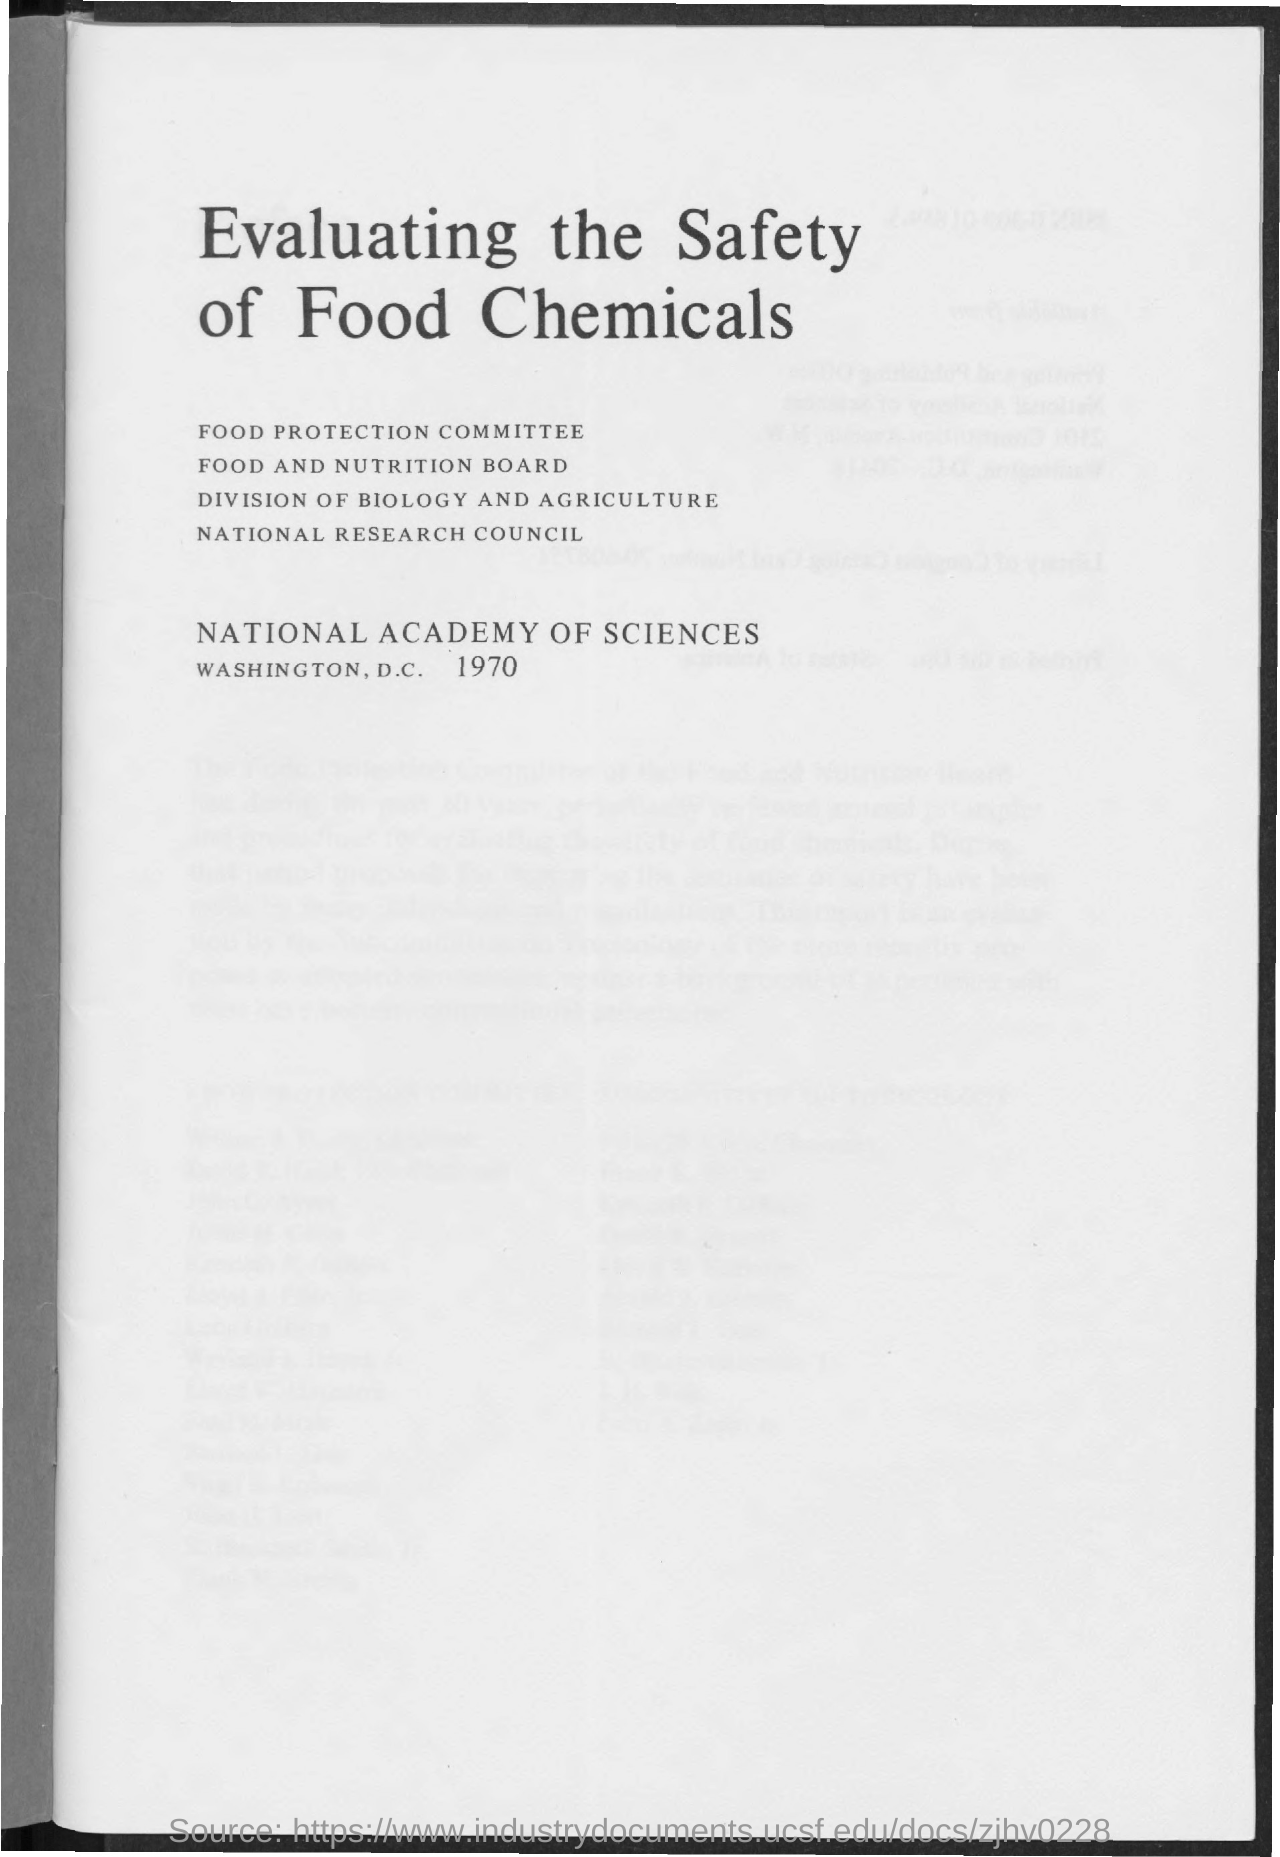What is the year mentioned in the document? The document displayed in the image is dated 1970, as indicated at the bottom of the title page, under the heading 'NATIONAL ACADEMY OF SCIENCES WASHINGTON, D.C.' This document appears to be a publication or report concerning the safety evaluation of food chemicals. 